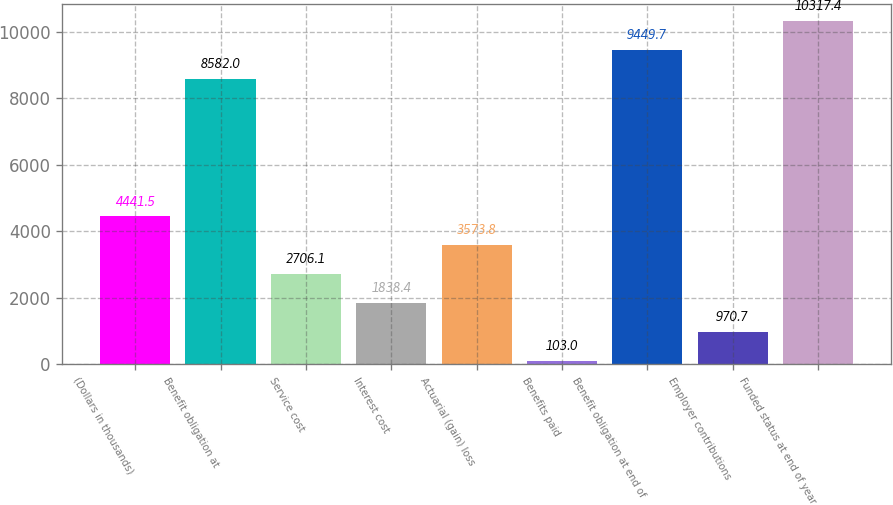Convert chart to OTSL. <chart><loc_0><loc_0><loc_500><loc_500><bar_chart><fcel>(Dollars in thousands)<fcel>Benefit obligation at<fcel>Service cost<fcel>Interest cost<fcel>Actuarial (gain) loss<fcel>Benefits paid<fcel>Benefit obligation at end of<fcel>Employer contributions<fcel>Funded status at end of year<nl><fcel>4441.5<fcel>8582<fcel>2706.1<fcel>1838.4<fcel>3573.8<fcel>103<fcel>9449.7<fcel>970.7<fcel>10317.4<nl></chart> 